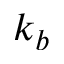Convert formula to latex. <formula><loc_0><loc_0><loc_500><loc_500>k _ { b }</formula> 